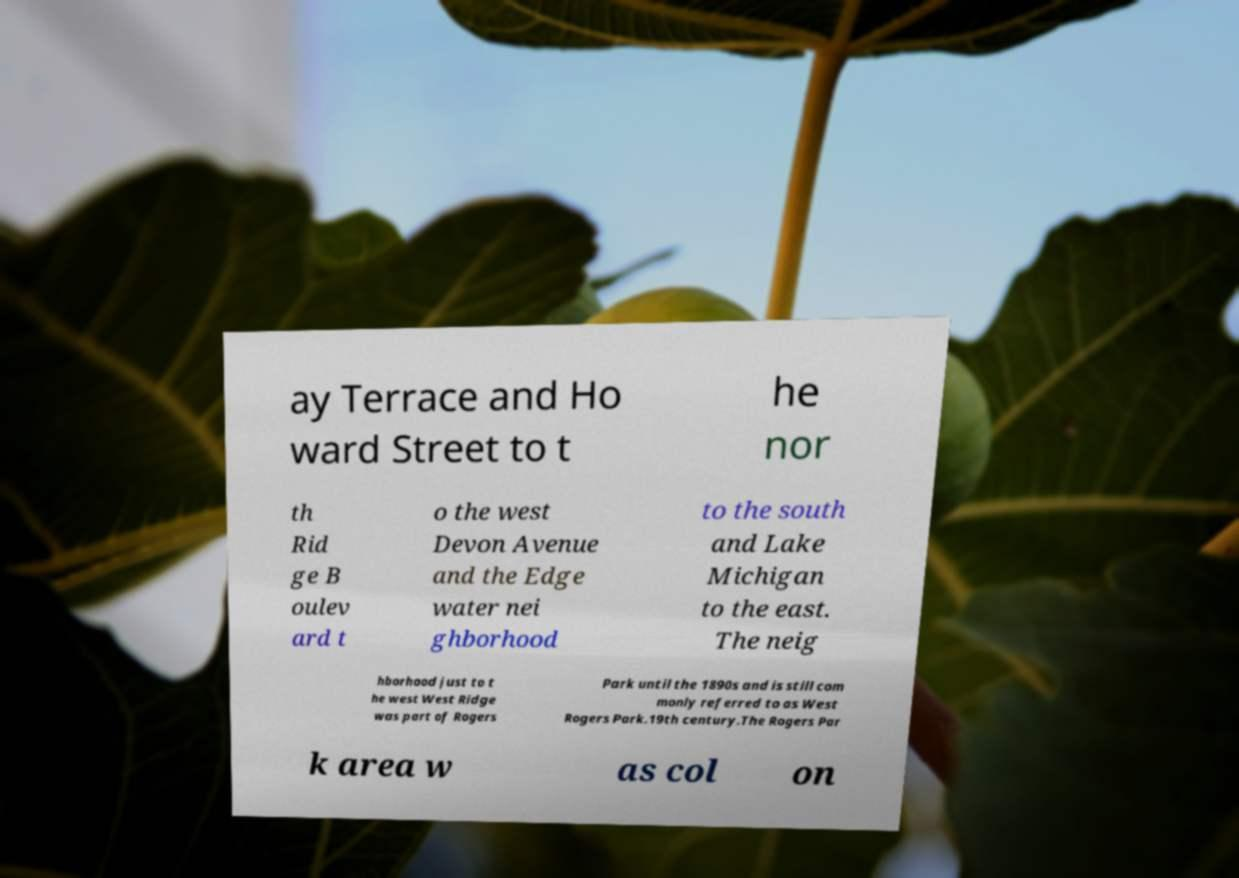Could you assist in decoding the text presented in this image and type it out clearly? ay Terrace and Ho ward Street to t he nor th Rid ge B oulev ard t o the west Devon Avenue and the Edge water nei ghborhood to the south and Lake Michigan to the east. The neig hborhood just to t he west West Ridge was part of Rogers Park until the 1890s and is still com monly referred to as West Rogers Park.19th century.The Rogers Par k area w as col on 